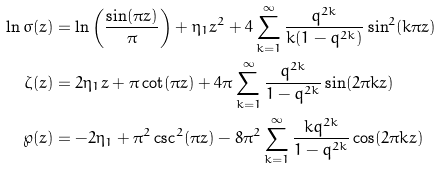<formula> <loc_0><loc_0><loc_500><loc_500>\ln \sigma ( z ) & = \ln \left ( \frac { \sin ( \pi z ) } { \pi } \right ) + \eta _ { 1 } z ^ { 2 } + 4 \sum _ { k = 1 } ^ { \infty } \frac { q ^ { 2 k } } { k ( 1 - q ^ { 2 k } ) } \sin ^ { 2 } ( k \pi z ) \\ \zeta ( z ) & = 2 \eta _ { 1 } z + \pi \cot ( \pi z ) + 4 \pi \sum _ { k = 1 } ^ { \infty } \frac { q ^ { 2 k } } { 1 - q ^ { 2 k } } \sin ( 2 \pi k z ) \\ \wp ( z ) & = - 2 \eta _ { 1 } + \pi ^ { 2 } \csc ^ { 2 } ( \pi z ) - 8 \pi ^ { 2 } \sum _ { k = 1 } ^ { \infty } \frac { k q ^ { 2 k } } { 1 - q ^ { 2 k } } \cos ( 2 \pi k z )</formula> 